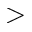<formula> <loc_0><loc_0><loc_500><loc_500>></formula> 